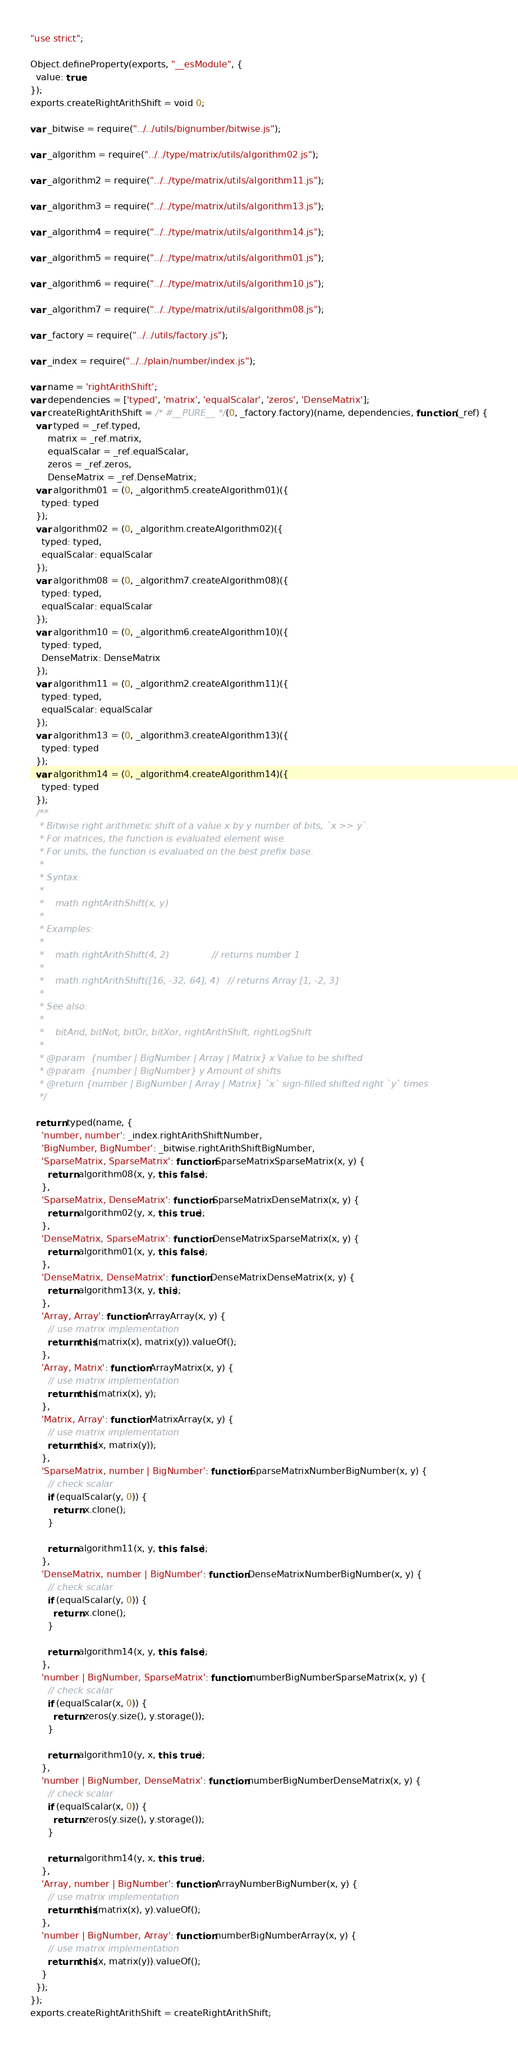Convert code to text. <code><loc_0><loc_0><loc_500><loc_500><_JavaScript_>"use strict";

Object.defineProperty(exports, "__esModule", {
  value: true
});
exports.createRightArithShift = void 0;

var _bitwise = require("../../utils/bignumber/bitwise.js");

var _algorithm = require("../../type/matrix/utils/algorithm02.js");

var _algorithm2 = require("../../type/matrix/utils/algorithm11.js");

var _algorithm3 = require("../../type/matrix/utils/algorithm13.js");

var _algorithm4 = require("../../type/matrix/utils/algorithm14.js");

var _algorithm5 = require("../../type/matrix/utils/algorithm01.js");

var _algorithm6 = require("../../type/matrix/utils/algorithm10.js");

var _algorithm7 = require("../../type/matrix/utils/algorithm08.js");

var _factory = require("../../utils/factory.js");

var _index = require("../../plain/number/index.js");

var name = 'rightArithShift';
var dependencies = ['typed', 'matrix', 'equalScalar', 'zeros', 'DenseMatrix'];
var createRightArithShift = /* #__PURE__ */(0, _factory.factory)(name, dependencies, function (_ref) {
  var typed = _ref.typed,
      matrix = _ref.matrix,
      equalScalar = _ref.equalScalar,
      zeros = _ref.zeros,
      DenseMatrix = _ref.DenseMatrix;
  var algorithm01 = (0, _algorithm5.createAlgorithm01)({
    typed: typed
  });
  var algorithm02 = (0, _algorithm.createAlgorithm02)({
    typed: typed,
    equalScalar: equalScalar
  });
  var algorithm08 = (0, _algorithm7.createAlgorithm08)({
    typed: typed,
    equalScalar: equalScalar
  });
  var algorithm10 = (0, _algorithm6.createAlgorithm10)({
    typed: typed,
    DenseMatrix: DenseMatrix
  });
  var algorithm11 = (0, _algorithm2.createAlgorithm11)({
    typed: typed,
    equalScalar: equalScalar
  });
  var algorithm13 = (0, _algorithm3.createAlgorithm13)({
    typed: typed
  });
  var algorithm14 = (0, _algorithm4.createAlgorithm14)({
    typed: typed
  });
  /**
   * Bitwise right arithmetic shift of a value x by y number of bits, `x >> y`.
   * For matrices, the function is evaluated element wise.
   * For units, the function is evaluated on the best prefix base.
   *
   * Syntax:
   *
   *    math.rightArithShift(x, y)
   *
   * Examples:
   *
   *    math.rightArithShift(4, 2)               // returns number 1
   *
   *    math.rightArithShift([16, -32, 64], 4)   // returns Array [1, -2, 3]
   *
   * See also:
   *
   *    bitAnd, bitNot, bitOr, bitXor, rightArithShift, rightLogShift
   *
   * @param  {number | BigNumber | Array | Matrix} x Value to be shifted
   * @param  {number | BigNumber} y Amount of shifts
   * @return {number | BigNumber | Array | Matrix} `x` sign-filled shifted right `y` times
   */

  return typed(name, {
    'number, number': _index.rightArithShiftNumber,
    'BigNumber, BigNumber': _bitwise.rightArithShiftBigNumber,
    'SparseMatrix, SparseMatrix': function SparseMatrixSparseMatrix(x, y) {
      return algorithm08(x, y, this, false);
    },
    'SparseMatrix, DenseMatrix': function SparseMatrixDenseMatrix(x, y) {
      return algorithm02(y, x, this, true);
    },
    'DenseMatrix, SparseMatrix': function DenseMatrixSparseMatrix(x, y) {
      return algorithm01(x, y, this, false);
    },
    'DenseMatrix, DenseMatrix': function DenseMatrixDenseMatrix(x, y) {
      return algorithm13(x, y, this);
    },
    'Array, Array': function ArrayArray(x, y) {
      // use matrix implementation
      return this(matrix(x), matrix(y)).valueOf();
    },
    'Array, Matrix': function ArrayMatrix(x, y) {
      // use matrix implementation
      return this(matrix(x), y);
    },
    'Matrix, Array': function MatrixArray(x, y) {
      // use matrix implementation
      return this(x, matrix(y));
    },
    'SparseMatrix, number | BigNumber': function SparseMatrixNumberBigNumber(x, y) {
      // check scalar
      if (equalScalar(y, 0)) {
        return x.clone();
      }

      return algorithm11(x, y, this, false);
    },
    'DenseMatrix, number | BigNumber': function DenseMatrixNumberBigNumber(x, y) {
      // check scalar
      if (equalScalar(y, 0)) {
        return x.clone();
      }

      return algorithm14(x, y, this, false);
    },
    'number | BigNumber, SparseMatrix': function numberBigNumberSparseMatrix(x, y) {
      // check scalar
      if (equalScalar(x, 0)) {
        return zeros(y.size(), y.storage());
      }

      return algorithm10(y, x, this, true);
    },
    'number | BigNumber, DenseMatrix': function numberBigNumberDenseMatrix(x, y) {
      // check scalar
      if (equalScalar(x, 0)) {
        return zeros(y.size(), y.storage());
      }

      return algorithm14(y, x, this, true);
    },
    'Array, number | BigNumber': function ArrayNumberBigNumber(x, y) {
      // use matrix implementation
      return this(matrix(x), y).valueOf();
    },
    'number | BigNumber, Array': function numberBigNumberArray(x, y) {
      // use matrix implementation
      return this(x, matrix(y)).valueOf();
    }
  });
});
exports.createRightArithShift = createRightArithShift;</code> 